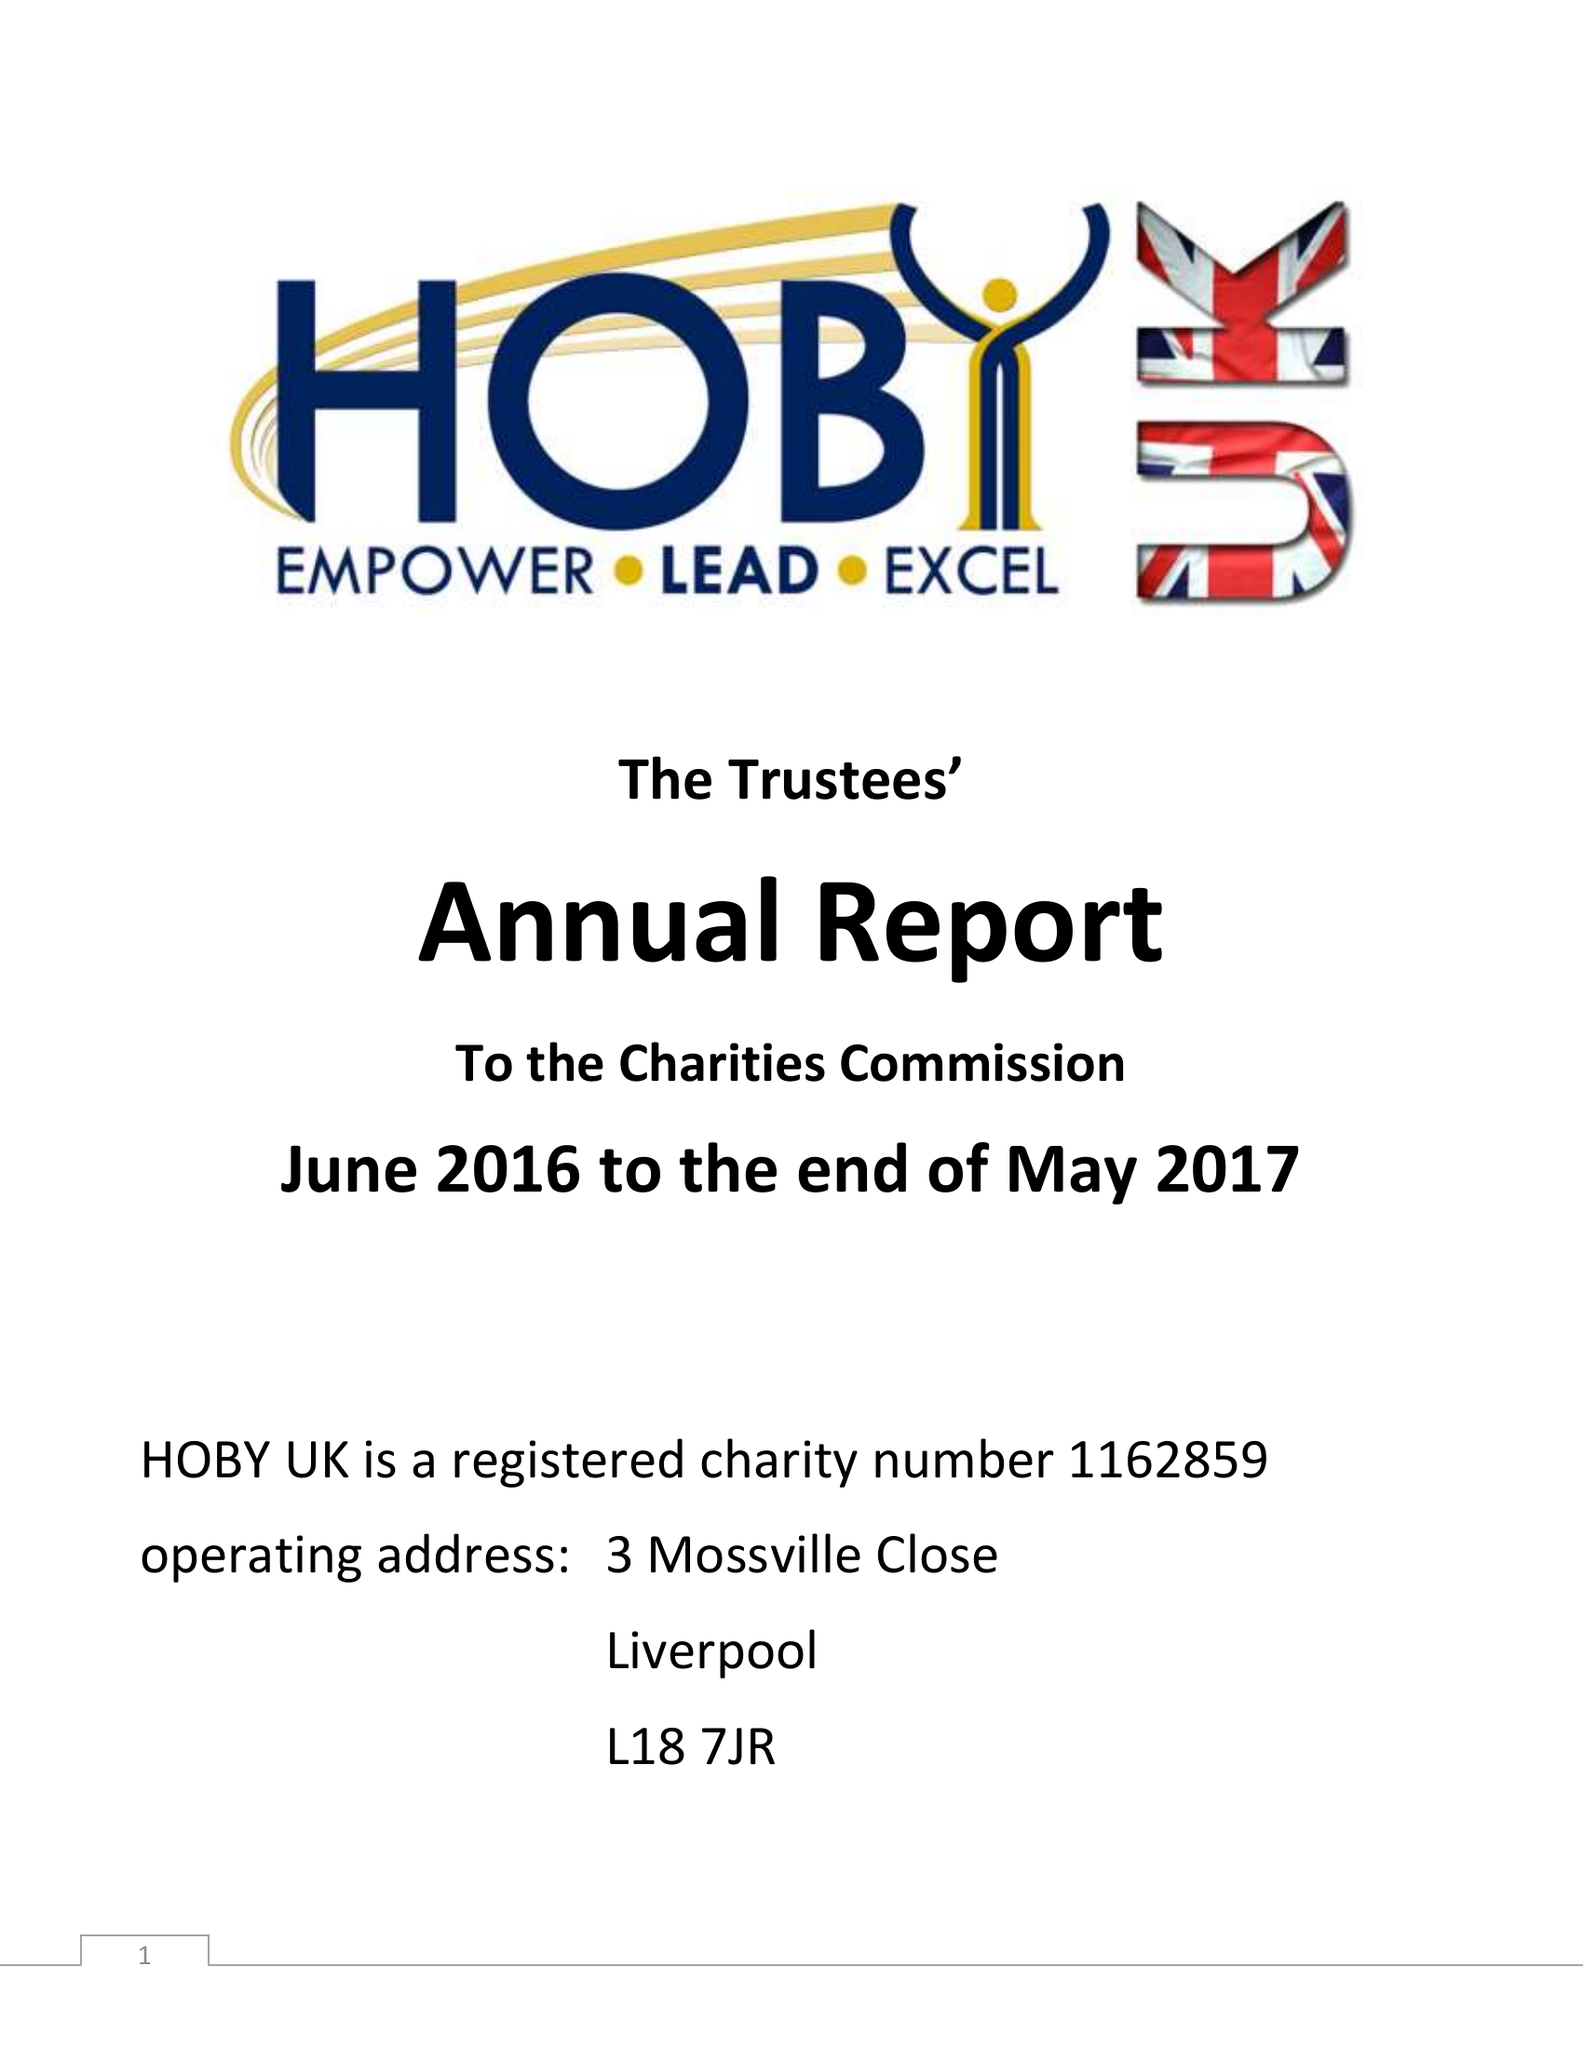What is the value for the address__post_town?
Answer the question using a single word or phrase. LIVERPOOL 